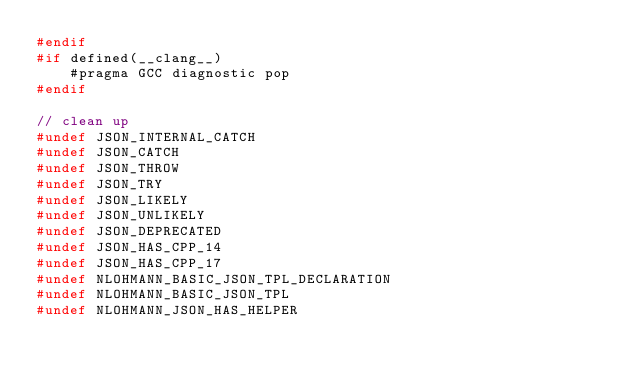Convert code to text. <code><loc_0><loc_0><loc_500><loc_500><_C++_>#endif
#if defined(__clang__)
    #pragma GCC diagnostic pop
#endif

// clean up
#undef JSON_INTERNAL_CATCH
#undef JSON_CATCH
#undef JSON_THROW
#undef JSON_TRY
#undef JSON_LIKELY
#undef JSON_UNLIKELY
#undef JSON_DEPRECATED
#undef JSON_HAS_CPP_14
#undef JSON_HAS_CPP_17
#undef NLOHMANN_BASIC_JSON_TPL_DECLARATION
#undef NLOHMANN_BASIC_JSON_TPL
#undef NLOHMANN_JSON_HAS_HELPER
</code> 